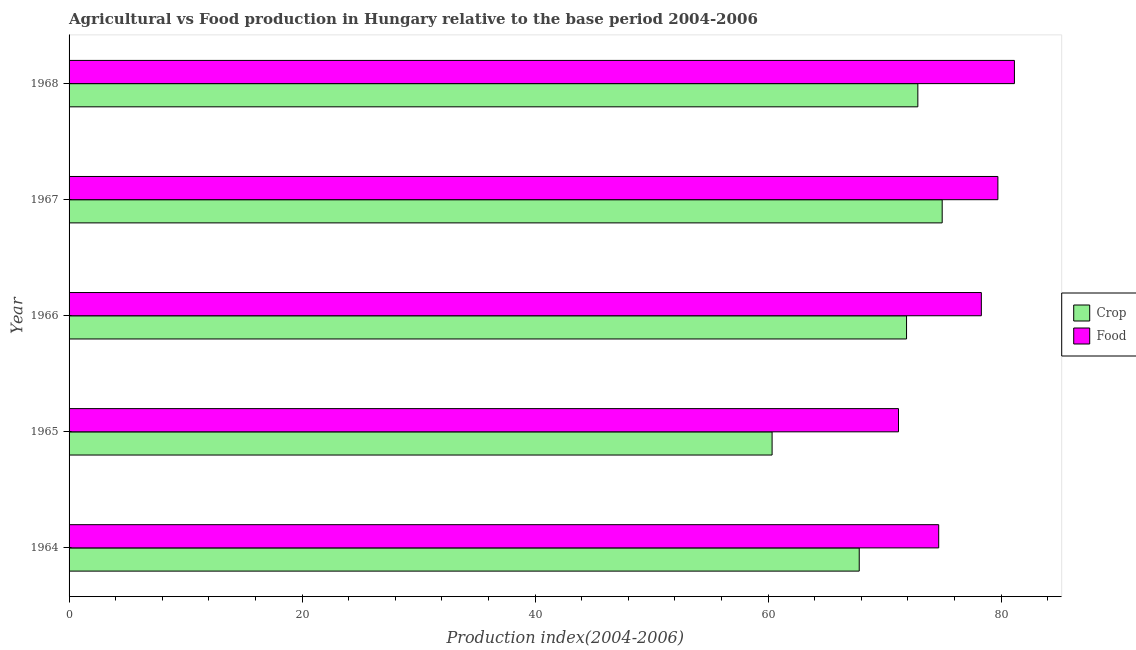How many groups of bars are there?
Ensure brevity in your answer.  5. Are the number of bars per tick equal to the number of legend labels?
Your answer should be compact. Yes. Are the number of bars on each tick of the Y-axis equal?
Your answer should be very brief. Yes. What is the label of the 1st group of bars from the top?
Your answer should be compact. 1968. In how many cases, is the number of bars for a given year not equal to the number of legend labels?
Provide a succinct answer. 0. What is the food production index in 1964?
Offer a terse response. 74.64. Across all years, what is the maximum crop production index?
Keep it short and to the point. 74.94. Across all years, what is the minimum crop production index?
Keep it short and to the point. 60.34. In which year was the crop production index maximum?
Give a very brief answer. 1967. In which year was the crop production index minimum?
Your answer should be very brief. 1965. What is the total crop production index in the graph?
Your answer should be compact. 347.83. What is the difference between the food production index in 1965 and that in 1966?
Provide a succinct answer. -7.11. What is the difference between the crop production index in 1966 and the food production index in 1968?
Provide a succinct answer. -9.26. What is the average food production index per year?
Make the answer very short. 77. In the year 1966, what is the difference between the food production index and crop production index?
Your answer should be compact. 6.42. What is the ratio of the crop production index in 1964 to that in 1968?
Give a very brief answer. 0.93. Is the food production index in 1964 less than that in 1965?
Make the answer very short. No. What is the difference between the highest and the second highest crop production index?
Provide a succinct answer. 2.09. What does the 2nd bar from the top in 1965 represents?
Keep it short and to the point. Crop. What does the 2nd bar from the bottom in 1966 represents?
Ensure brevity in your answer.  Food. How many bars are there?
Your answer should be very brief. 10. How many years are there in the graph?
Provide a succinct answer. 5. Does the graph contain any zero values?
Offer a very short reply. No. How many legend labels are there?
Provide a succinct answer. 2. What is the title of the graph?
Keep it short and to the point. Agricultural vs Food production in Hungary relative to the base period 2004-2006. What is the label or title of the X-axis?
Make the answer very short. Production index(2004-2006). What is the Production index(2004-2006) in Crop in 1964?
Offer a very short reply. 67.82. What is the Production index(2004-2006) in Food in 1964?
Give a very brief answer. 74.64. What is the Production index(2004-2006) of Crop in 1965?
Ensure brevity in your answer.  60.34. What is the Production index(2004-2006) of Food in 1965?
Ensure brevity in your answer.  71.19. What is the Production index(2004-2006) in Crop in 1966?
Offer a terse response. 71.88. What is the Production index(2004-2006) of Food in 1966?
Provide a succinct answer. 78.3. What is the Production index(2004-2006) of Crop in 1967?
Keep it short and to the point. 74.94. What is the Production index(2004-2006) of Food in 1967?
Provide a short and direct response. 79.72. What is the Production index(2004-2006) of Crop in 1968?
Make the answer very short. 72.85. What is the Production index(2004-2006) in Food in 1968?
Make the answer very short. 81.14. Across all years, what is the maximum Production index(2004-2006) of Crop?
Your response must be concise. 74.94. Across all years, what is the maximum Production index(2004-2006) in Food?
Your answer should be very brief. 81.14. Across all years, what is the minimum Production index(2004-2006) of Crop?
Your response must be concise. 60.34. Across all years, what is the minimum Production index(2004-2006) in Food?
Offer a terse response. 71.19. What is the total Production index(2004-2006) of Crop in the graph?
Your answer should be compact. 347.83. What is the total Production index(2004-2006) of Food in the graph?
Make the answer very short. 384.99. What is the difference between the Production index(2004-2006) in Crop in 1964 and that in 1965?
Provide a short and direct response. 7.48. What is the difference between the Production index(2004-2006) of Food in 1964 and that in 1965?
Make the answer very short. 3.45. What is the difference between the Production index(2004-2006) of Crop in 1964 and that in 1966?
Your response must be concise. -4.06. What is the difference between the Production index(2004-2006) of Food in 1964 and that in 1966?
Offer a terse response. -3.66. What is the difference between the Production index(2004-2006) in Crop in 1964 and that in 1967?
Keep it short and to the point. -7.12. What is the difference between the Production index(2004-2006) of Food in 1964 and that in 1967?
Your answer should be compact. -5.08. What is the difference between the Production index(2004-2006) of Crop in 1964 and that in 1968?
Keep it short and to the point. -5.03. What is the difference between the Production index(2004-2006) in Crop in 1965 and that in 1966?
Offer a very short reply. -11.54. What is the difference between the Production index(2004-2006) of Food in 1965 and that in 1966?
Ensure brevity in your answer.  -7.11. What is the difference between the Production index(2004-2006) of Crop in 1965 and that in 1967?
Ensure brevity in your answer.  -14.6. What is the difference between the Production index(2004-2006) of Food in 1965 and that in 1967?
Your answer should be compact. -8.53. What is the difference between the Production index(2004-2006) in Crop in 1965 and that in 1968?
Keep it short and to the point. -12.51. What is the difference between the Production index(2004-2006) of Food in 1965 and that in 1968?
Provide a short and direct response. -9.95. What is the difference between the Production index(2004-2006) in Crop in 1966 and that in 1967?
Your answer should be compact. -3.06. What is the difference between the Production index(2004-2006) in Food in 1966 and that in 1967?
Your response must be concise. -1.42. What is the difference between the Production index(2004-2006) of Crop in 1966 and that in 1968?
Your answer should be compact. -0.97. What is the difference between the Production index(2004-2006) in Food in 1966 and that in 1968?
Your answer should be compact. -2.84. What is the difference between the Production index(2004-2006) of Crop in 1967 and that in 1968?
Provide a short and direct response. 2.09. What is the difference between the Production index(2004-2006) in Food in 1967 and that in 1968?
Offer a very short reply. -1.42. What is the difference between the Production index(2004-2006) of Crop in 1964 and the Production index(2004-2006) of Food in 1965?
Provide a succinct answer. -3.37. What is the difference between the Production index(2004-2006) in Crop in 1964 and the Production index(2004-2006) in Food in 1966?
Your answer should be compact. -10.48. What is the difference between the Production index(2004-2006) in Crop in 1964 and the Production index(2004-2006) in Food in 1968?
Give a very brief answer. -13.32. What is the difference between the Production index(2004-2006) of Crop in 1965 and the Production index(2004-2006) of Food in 1966?
Give a very brief answer. -17.96. What is the difference between the Production index(2004-2006) in Crop in 1965 and the Production index(2004-2006) in Food in 1967?
Ensure brevity in your answer.  -19.38. What is the difference between the Production index(2004-2006) of Crop in 1965 and the Production index(2004-2006) of Food in 1968?
Provide a short and direct response. -20.8. What is the difference between the Production index(2004-2006) in Crop in 1966 and the Production index(2004-2006) in Food in 1967?
Provide a short and direct response. -7.84. What is the difference between the Production index(2004-2006) in Crop in 1966 and the Production index(2004-2006) in Food in 1968?
Your response must be concise. -9.26. What is the average Production index(2004-2006) in Crop per year?
Provide a succinct answer. 69.57. What is the average Production index(2004-2006) of Food per year?
Offer a terse response. 77. In the year 1964, what is the difference between the Production index(2004-2006) of Crop and Production index(2004-2006) of Food?
Offer a terse response. -6.82. In the year 1965, what is the difference between the Production index(2004-2006) of Crop and Production index(2004-2006) of Food?
Make the answer very short. -10.85. In the year 1966, what is the difference between the Production index(2004-2006) of Crop and Production index(2004-2006) of Food?
Ensure brevity in your answer.  -6.42. In the year 1967, what is the difference between the Production index(2004-2006) in Crop and Production index(2004-2006) in Food?
Make the answer very short. -4.78. In the year 1968, what is the difference between the Production index(2004-2006) of Crop and Production index(2004-2006) of Food?
Ensure brevity in your answer.  -8.29. What is the ratio of the Production index(2004-2006) in Crop in 1964 to that in 1965?
Provide a succinct answer. 1.12. What is the ratio of the Production index(2004-2006) of Food in 1964 to that in 1965?
Offer a terse response. 1.05. What is the ratio of the Production index(2004-2006) of Crop in 1964 to that in 1966?
Your answer should be compact. 0.94. What is the ratio of the Production index(2004-2006) of Food in 1964 to that in 1966?
Your response must be concise. 0.95. What is the ratio of the Production index(2004-2006) in Crop in 1964 to that in 1967?
Provide a short and direct response. 0.91. What is the ratio of the Production index(2004-2006) in Food in 1964 to that in 1967?
Make the answer very short. 0.94. What is the ratio of the Production index(2004-2006) of Crop in 1964 to that in 1968?
Provide a succinct answer. 0.93. What is the ratio of the Production index(2004-2006) in Food in 1964 to that in 1968?
Offer a terse response. 0.92. What is the ratio of the Production index(2004-2006) of Crop in 1965 to that in 1966?
Offer a terse response. 0.84. What is the ratio of the Production index(2004-2006) in Food in 1965 to that in 1966?
Provide a succinct answer. 0.91. What is the ratio of the Production index(2004-2006) of Crop in 1965 to that in 1967?
Offer a terse response. 0.81. What is the ratio of the Production index(2004-2006) in Food in 1965 to that in 1967?
Make the answer very short. 0.89. What is the ratio of the Production index(2004-2006) in Crop in 1965 to that in 1968?
Your response must be concise. 0.83. What is the ratio of the Production index(2004-2006) of Food in 1965 to that in 1968?
Keep it short and to the point. 0.88. What is the ratio of the Production index(2004-2006) of Crop in 1966 to that in 1967?
Offer a very short reply. 0.96. What is the ratio of the Production index(2004-2006) in Food in 1966 to that in 1967?
Provide a succinct answer. 0.98. What is the ratio of the Production index(2004-2006) of Crop in 1966 to that in 1968?
Ensure brevity in your answer.  0.99. What is the ratio of the Production index(2004-2006) in Food in 1966 to that in 1968?
Provide a succinct answer. 0.96. What is the ratio of the Production index(2004-2006) of Crop in 1967 to that in 1968?
Keep it short and to the point. 1.03. What is the ratio of the Production index(2004-2006) in Food in 1967 to that in 1968?
Provide a short and direct response. 0.98. What is the difference between the highest and the second highest Production index(2004-2006) of Crop?
Your answer should be compact. 2.09. What is the difference between the highest and the second highest Production index(2004-2006) in Food?
Make the answer very short. 1.42. What is the difference between the highest and the lowest Production index(2004-2006) in Crop?
Offer a very short reply. 14.6. What is the difference between the highest and the lowest Production index(2004-2006) in Food?
Offer a very short reply. 9.95. 